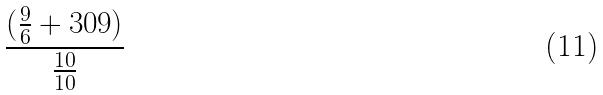<formula> <loc_0><loc_0><loc_500><loc_500>\frac { ( \frac { 9 } { 6 } + 3 0 9 ) } { \frac { 1 0 } { 1 0 } }</formula> 